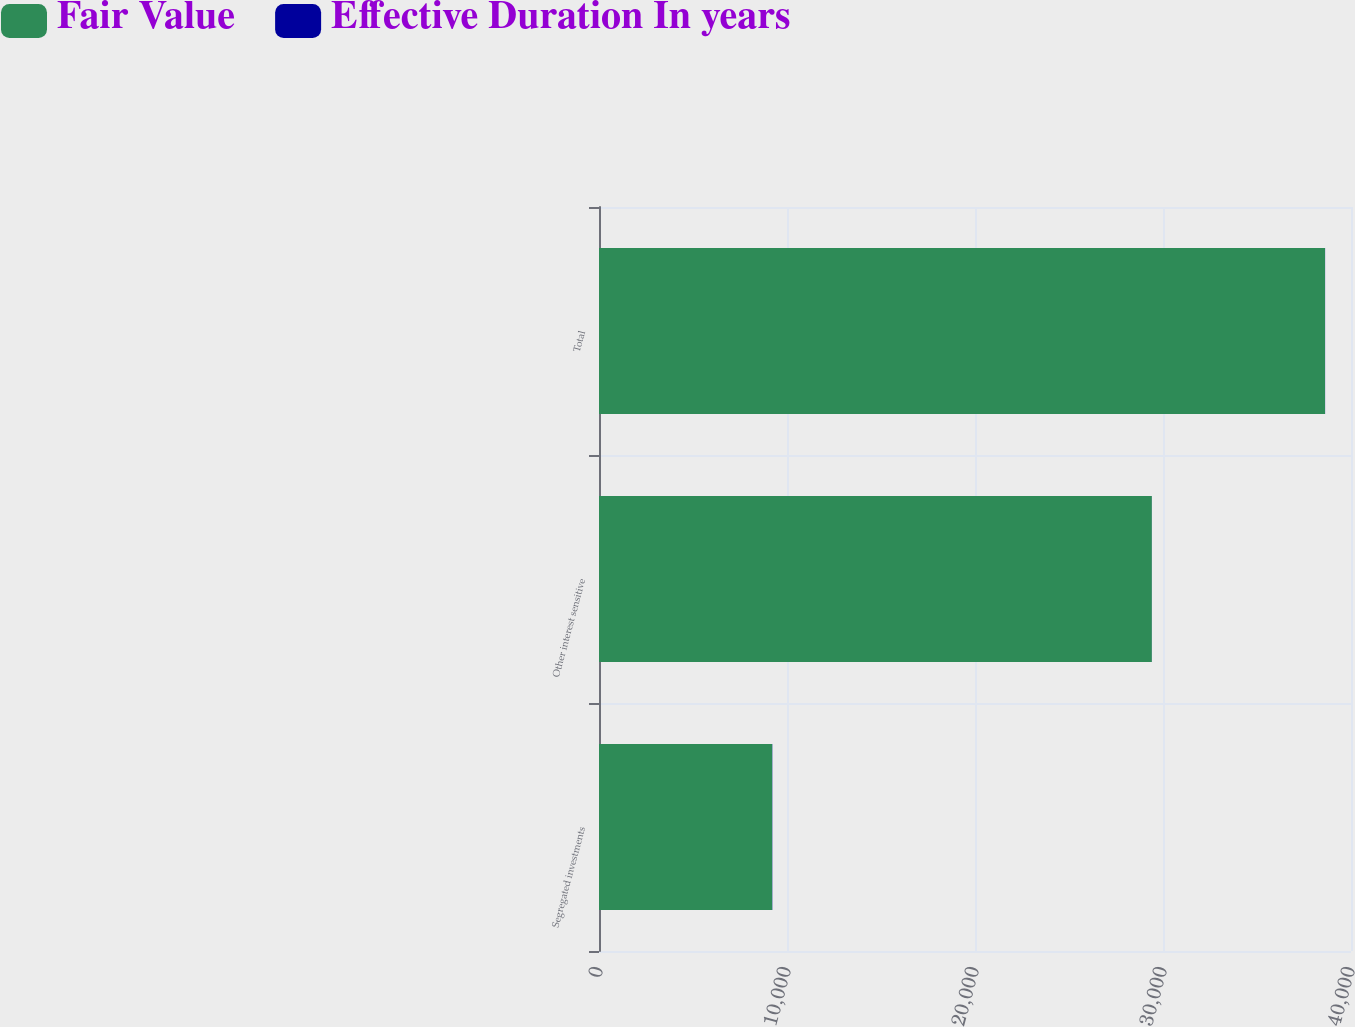<chart> <loc_0><loc_0><loc_500><loc_500><stacked_bar_chart><ecel><fcel>Segregated investments<fcel>Other interest sensitive<fcel>Total<nl><fcel>Fair Value<fcel>9211<fcel>29406<fcel>38617<nl><fcel>Effective Duration In years<fcel>10.7<fcel>3.3<fcel>5.1<nl></chart> 